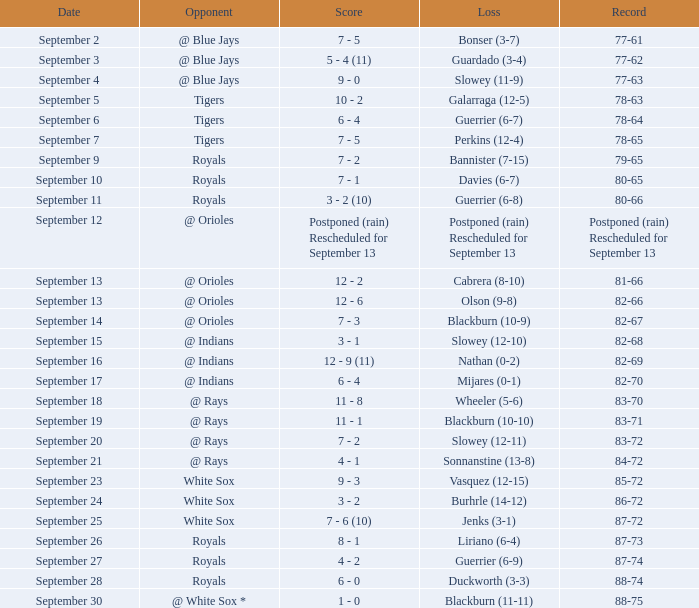When was the 77-62 record established? September 3. 